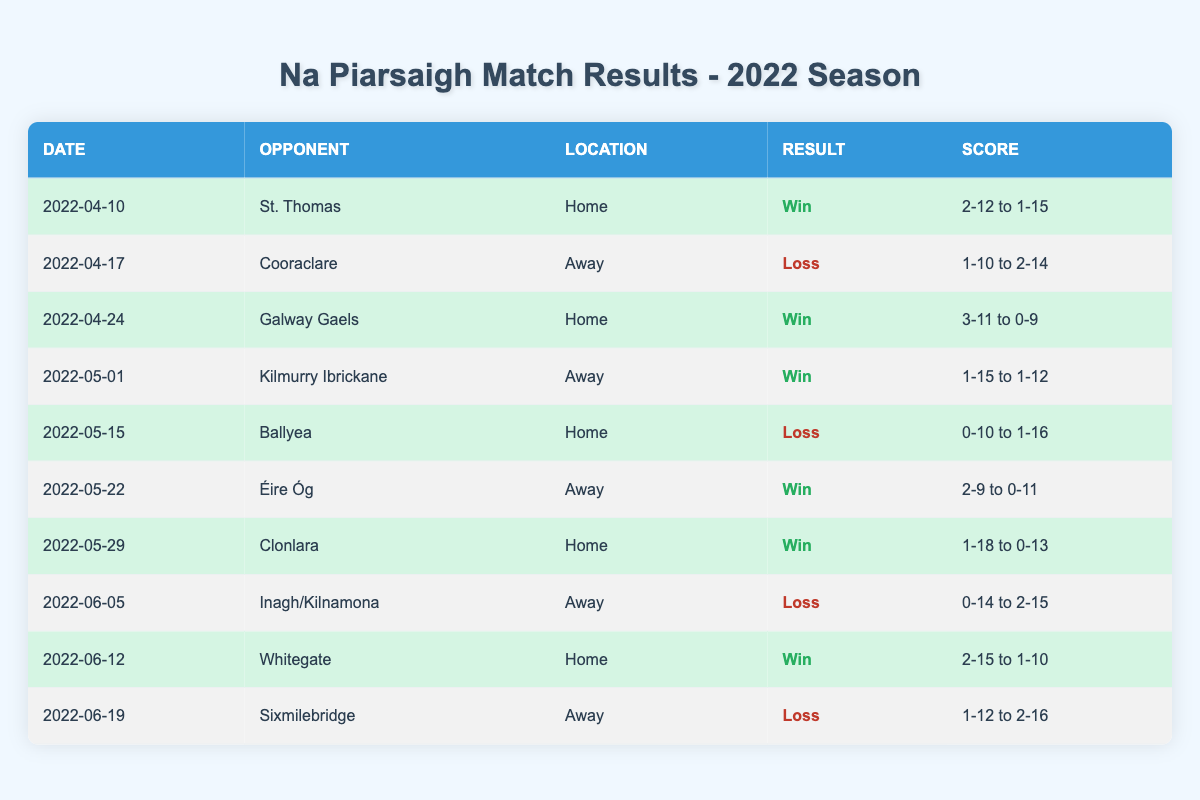What was the outcome of the match against St. Thomas? In the table, the row for the match against St. Thomas on April 10, 2022, shows the result as "Win." Hence, Na Piarsaigh won this match.
Answer: Win How many total matches did Na Piarsaigh play in the season? By counting the rows in the table, there are 10 matches listed.
Answer: 10 What was the score in the match against Cooraclare? The row for Cooraclare dated April 17, 2022, shows the score as "1-10 to 2-14." This means Na Piarsaigh scored 1-10 and Cooraclare scored 2-14.
Answer: 1-10 to 2-14 Did Na Piarsaigh win more games at home than away? Counting the wins at home, they won 4 times (against St. Thomas, Galway Gaels, Clonlara, and Whitegate). For away matches, they won 3 times (against Kilmurry Ibrickane and Éire Óg). Since 4 is greater than 3, Na Piarsaigh won more at home.
Answer: Yes What is the average score Na Piarsaigh achieved in their wins? They won 4 matches with the following scores: 2-12 (St. Thomas), 3-11 (Galway Gaels), 1-15 (Kilmurry Ibrickane), and 2-9 (Éire Óg). Converting scores to totals for the average: 2-12 is 18, 3-11 is 20, 1-15 is 18, and 2-9 is 15. The total is 18 + 20 + 18 + 15 = 71 and there are 4 matches, so the average score is 71/4 = 17.75.
Answer: 17.75 What was the result of the last match of the season? The last match listed is against Sixmilebridge on June 19, 2022, and the outcome in the table indicates a "Loss." Therefore, they did not win this match.
Answer: Loss How many matches did Na Piarsaigh lose when playing at home? From the table, while playing at home, they had 3 matches: they lost against Ballyea (0-10 to 1-16) and won against St. Thomas and Galway Gaels, making the total losses at home equal to 1.
Answer: 1 What was the score difference in the match against Whitegate? The score against Whitegate on June 12, 2022, is listed as "2-15 to 1-10." Converting to total points, Na Piarsaigh scored 21 and Whitegate scored 13. The difference in scores is 21 - 13 = 8 points.
Answer: 8 Which opponent did Na Piarsaigh face on May 15, 2022? Looking at the table, the match listed on May 15, 2022, was against Ballyea. Therefore, Ballyea was their opponent on that date.
Answer: Ballyea 